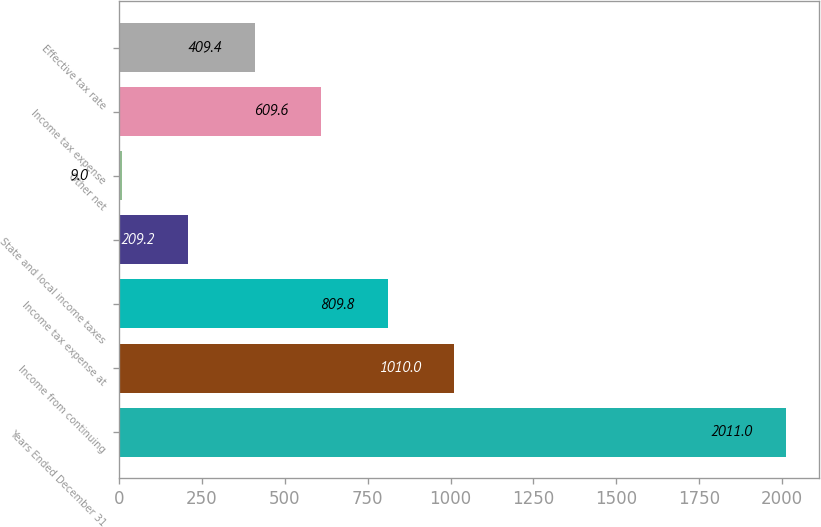Convert chart. <chart><loc_0><loc_0><loc_500><loc_500><bar_chart><fcel>Years Ended December 31<fcel>Income from continuing<fcel>Income tax expense at<fcel>State and local income taxes<fcel>Other net<fcel>Income tax expense<fcel>Effective tax rate<nl><fcel>2011<fcel>1010<fcel>809.8<fcel>209.2<fcel>9<fcel>609.6<fcel>409.4<nl></chart> 